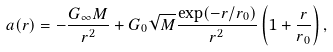Convert formula to latex. <formula><loc_0><loc_0><loc_500><loc_500>a ( r ) = - \frac { G _ { \infty } M } { r ^ { 2 } } + G _ { 0 } \sqrt { M } \frac { \exp ( - r / r _ { 0 } ) } { r ^ { 2 } } \left ( 1 + \frac { r } { r _ { 0 } } \right ) ,</formula> 